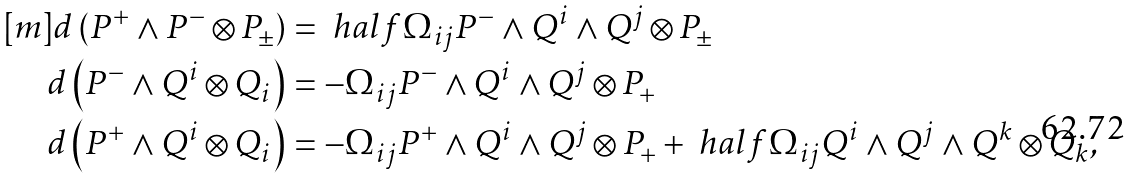Convert formula to latex. <formula><loc_0><loc_0><loc_500><loc_500>[ m ] d \left ( P ^ { + } \wedge P ^ { - } \otimes P _ { \pm } \right ) & = \ h a l f \Omega _ { i j } P ^ { - } \wedge Q ^ { i } \wedge Q ^ { j } \otimes P _ { \pm } \\ d \left ( P ^ { - } \wedge Q ^ { i } \otimes Q _ { i } \right ) & = - \Omega _ { i j } P ^ { - } \wedge Q ^ { i } \wedge Q ^ { j } \otimes P _ { + } \\ d \left ( P ^ { + } \wedge Q ^ { i } \otimes Q _ { i } \right ) & = - \Omega _ { i j } P ^ { + } \wedge Q ^ { i } \wedge Q ^ { j } \otimes P _ { + } + \ h a l f \Omega _ { i j } Q ^ { i } \wedge Q ^ { j } \wedge Q ^ { k } \otimes Q _ { k } ,</formula> 